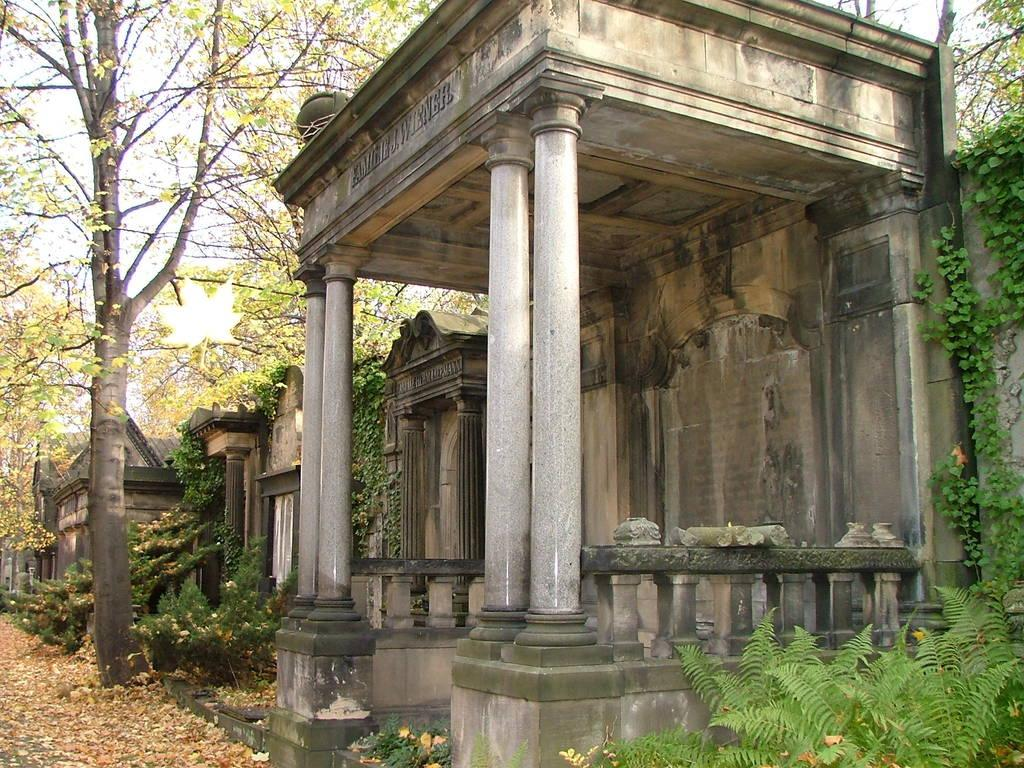What is the main structure in the center of the image? There is a shelter in the center of the image. What other types of buildings can be seen in the image? There are houses in the image. What type of natural environment is present in the image? There is greenery in the image. What can be seen in the background of the image? The sky is visible in the background of the image. What type of feast is being prepared in the image? There is no indication of a feast or any food preparation in the image. What kind of steel objects can be seen in the image? There is no steel object present in the image. 